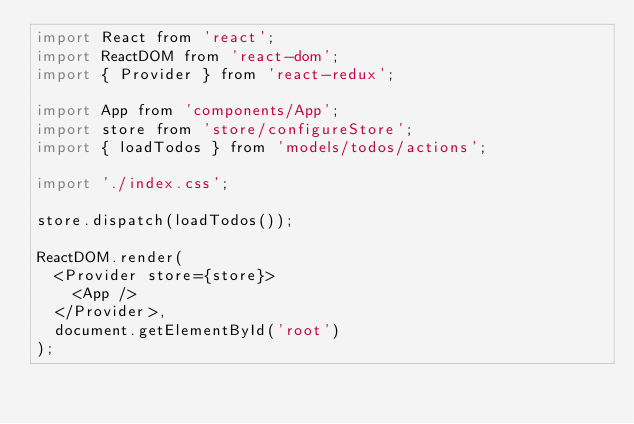Convert code to text. <code><loc_0><loc_0><loc_500><loc_500><_JavaScript_>import React from 'react';
import ReactDOM from 'react-dom';
import { Provider } from 'react-redux';

import App from 'components/App';
import store from 'store/configureStore';
import { loadTodos } from 'models/todos/actions';

import './index.css';

store.dispatch(loadTodos());

ReactDOM.render(
  <Provider store={store}>
    <App />
  </Provider>,
  document.getElementById('root')
);
</code> 